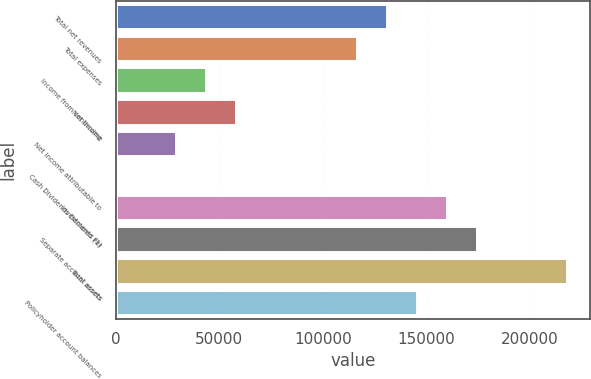<chart> <loc_0><loc_0><loc_500><loc_500><bar_chart><fcel>Total net revenues<fcel>Total expenses<fcel>Income from continuing<fcel>Net income<fcel>Net income attributable to<fcel>Cash Dividends Declared Per<fcel>Investments (1)<fcel>Separate account assets<fcel>Total assets<fcel>Policyholder account balances<nl><fcel>130805<fcel>116272<fcel>43603.5<fcel>58137.2<fcel>29069.9<fcel>2.59<fcel>159873<fcel>174406<fcel>218007<fcel>145339<nl></chart> 